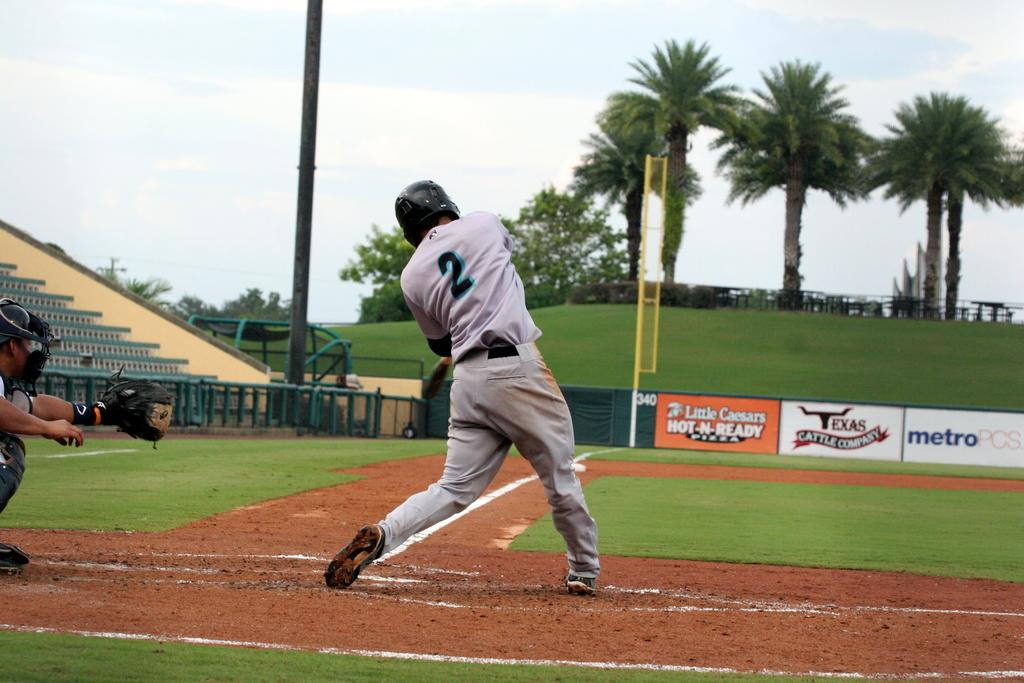<image>
Give a short and clear explanation of the subsequent image. Player number 2 is taking his turn at bat and swinging at the ball. 